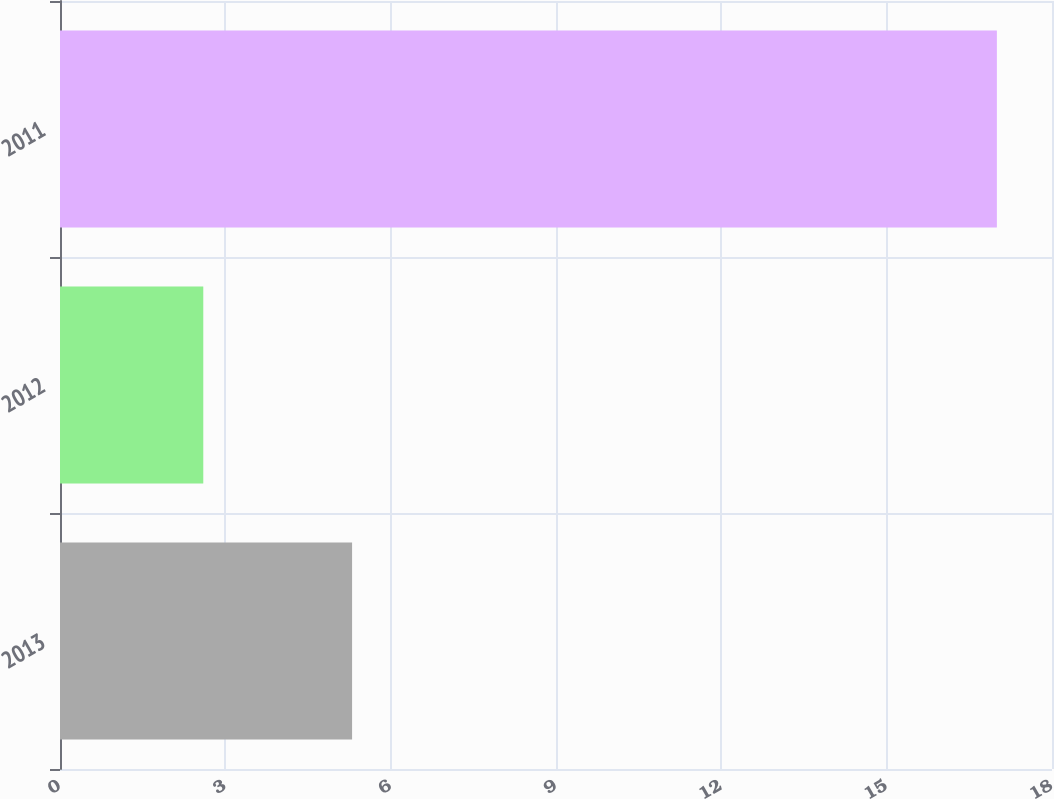<chart> <loc_0><loc_0><loc_500><loc_500><bar_chart><fcel>2013<fcel>2012<fcel>2011<nl><fcel>5.3<fcel>2.6<fcel>17<nl></chart> 